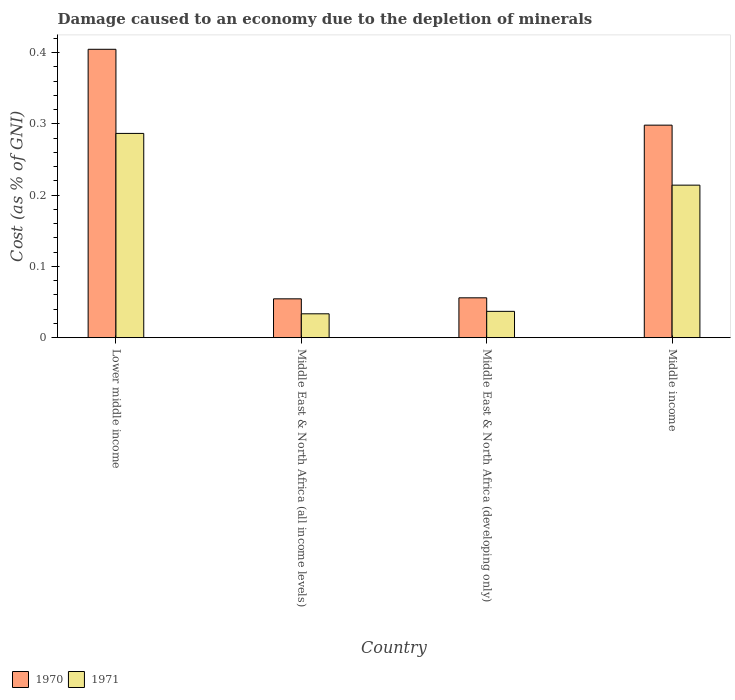How many groups of bars are there?
Give a very brief answer. 4. How many bars are there on the 3rd tick from the right?
Ensure brevity in your answer.  2. What is the cost of damage caused due to the depletion of minerals in 1971 in Middle East & North Africa (developing only)?
Give a very brief answer. 0.04. Across all countries, what is the maximum cost of damage caused due to the depletion of minerals in 1971?
Ensure brevity in your answer.  0.29. Across all countries, what is the minimum cost of damage caused due to the depletion of minerals in 1970?
Offer a terse response. 0.05. In which country was the cost of damage caused due to the depletion of minerals in 1971 maximum?
Offer a terse response. Lower middle income. In which country was the cost of damage caused due to the depletion of minerals in 1971 minimum?
Your answer should be very brief. Middle East & North Africa (all income levels). What is the total cost of damage caused due to the depletion of minerals in 1970 in the graph?
Your response must be concise. 0.81. What is the difference between the cost of damage caused due to the depletion of minerals in 1971 in Lower middle income and that in Middle East & North Africa (all income levels)?
Your answer should be very brief. 0.25. What is the difference between the cost of damage caused due to the depletion of minerals in 1970 in Middle income and the cost of damage caused due to the depletion of minerals in 1971 in Middle East & North Africa (developing only)?
Offer a very short reply. 0.26. What is the average cost of damage caused due to the depletion of minerals in 1971 per country?
Make the answer very short. 0.14. What is the difference between the cost of damage caused due to the depletion of minerals of/in 1970 and cost of damage caused due to the depletion of minerals of/in 1971 in Lower middle income?
Give a very brief answer. 0.12. In how many countries, is the cost of damage caused due to the depletion of minerals in 1971 greater than 0.30000000000000004 %?
Offer a very short reply. 0. What is the ratio of the cost of damage caused due to the depletion of minerals in 1971 in Lower middle income to that in Middle East & North Africa (developing only)?
Ensure brevity in your answer.  7.76. Is the difference between the cost of damage caused due to the depletion of minerals in 1970 in Lower middle income and Middle East & North Africa (developing only) greater than the difference between the cost of damage caused due to the depletion of minerals in 1971 in Lower middle income and Middle East & North Africa (developing only)?
Offer a very short reply. Yes. What is the difference between the highest and the second highest cost of damage caused due to the depletion of minerals in 1971?
Offer a very short reply. 0.25. What is the difference between the highest and the lowest cost of damage caused due to the depletion of minerals in 1970?
Keep it short and to the point. 0.35. In how many countries, is the cost of damage caused due to the depletion of minerals in 1971 greater than the average cost of damage caused due to the depletion of minerals in 1971 taken over all countries?
Offer a terse response. 2. What does the 2nd bar from the left in Middle East & North Africa (all income levels) represents?
Your response must be concise. 1971. What does the 1st bar from the right in Lower middle income represents?
Your response must be concise. 1971. How many bars are there?
Offer a terse response. 8. Are the values on the major ticks of Y-axis written in scientific E-notation?
Ensure brevity in your answer.  No. Does the graph contain grids?
Ensure brevity in your answer.  No. Where does the legend appear in the graph?
Your answer should be very brief. Bottom left. How many legend labels are there?
Ensure brevity in your answer.  2. What is the title of the graph?
Provide a succinct answer. Damage caused to an economy due to the depletion of minerals. What is the label or title of the X-axis?
Your answer should be compact. Country. What is the label or title of the Y-axis?
Provide a succinct answer. Cost (as % of GNI). What is the Cost (as % of GNI) of 1970 in Lower middle income?
Provide a short and direct response. 0.4. What is the Cost (as % of GNI) of 1971 in Lower middle income?
Offer a very short reply. 0.29. What is the Cost (as % of GNI) of 1970 in Middle East & North Africa (all income levels)?
Ensure brevity in your answer.  0.05. What is the Cost (as % of GNI) in 1971 in Middle East & North Africa (all income levels)?
Your answer should be compact. 0.03. What is the Cost (as % of GNI) in 1970 in Middle East & North Africa (developing only)?
Give a very brief answer. 0.06. What is the Cost (as % of GNI) in 1971 in Middle East & North Africa (developing only)?
Your answer should be very brief. 0.04. What is the Cost (as % of GNI) of 1970 in Middle income?
Provide a short and direct response. 0.3. What is the Cost (as % of GNI) in 1971 in Middle income?
Give a very brief answer. 0.21. Across all countries, what is the maximum Cost (as % of GNI) in 1970?
Provide a short and direct response. 0.4. Across all countries, what is the maximum Cost (as % of GNI) of 1971?
Offer a terse response. 0.29. Across all countries, what is the minimum Cost (as % of GNI) of 1970?
Offer a very short reply. 0.05. Across all countries, what is the minimum Cost (as % of GNI) of 1971?
Keep it short and to the point. 0.03. What is the total Cost (as % of GNI) of 1970 in the graph?
Ensure brevity in your answer.  0.81. What is the total Cost (as % of GNI) in 1971 in the graph?
Your answer should be compact. 0.57. What is the difference between the Cost (as % of GNI) in 1970 in Lower middle income and that in Middle East & North Africa (all income levels)?
Keep it short and to the point. 0.35. What is the difference between the Cost (as % of GNI) in 1971 in Lower middle income and that in Middle East & North Africa (all income levels)?
Your answer should be compact. 0.25. What is the difference between the Cost (as % of GNI) of 1970 in Lower middle income and that in Middle East & North Africa (developing only)?
Your response must be concise. 0.35. What is the difference between the Cost (as % of GNI) in 1971 in Lower middle income and that in Middle East & North Africa (developing only)?
Your answer should be very brief. 0.25. What is the difference between the Cost (as % of GNI) of 1970 in Lower middle income and that in Middle income?
Your answer should be very brief. 0.11. What is the difference between the Cost (as % of GNI) of 1971 in Lower middle income and that in Middle income?
Your response must be concise. 0.07. What is the difference between the Cost (as % of GNI) of 1970 in Middle East & North Africa (all income levels) and that in Middle East & North Africa (developing only)?
Provide a short and direct response. -0. What is the difference between the Cost (as % of GNI) in 1971 in Middle East & North Africa (all income levels) and that in Middle East & North Africa (developing only)?
Provide a succinct answer. -0. What is the difference between the Cost (as % of GNI) in 1970 in Middle East & North Africa (all income levels) and that in Middle income?
Provide a succinct answer. -0.24. What is the difference between the Cost (as % of GNI) in 1971 in Middle East & North Africa (all income levels) and that in Middle income?
Provide a short and direct response. -0.18. What is the difference between the Cost (as % of GNI) in 1970 in Middle East & North Africa (developing only) and that in Middle income?
Offer a very short reply. -0.24. What is the difference between the Cost (as % of GNI) in 1971 in Middle East & North Africa (developing only) and that in Middle income?
Your answer should be very brief. -0.18. What is the difference between the Cost (as % of GNI) in 1970 in Lower middle income and the Cost (as % of GNI) in 1971 in Middle East & North Africa (all income levels)?
Your response must be concise. 0.37. What is the difference between the Cost (as % of GNI) of 1970 in Lower middle income and the Cost (as % of GNI) of 1971 in Middle East & North Africa (developing only)?
Ensure brevity in your answer.  0.37. What is the difference between the Cost (as % of GNI) in 1970 in Lower middle income and the Cost (as % of GNI) in 1971 in Middle income?
Offer a very short reply. 0.19. What is the difference between the Cost (as % of GNI) of 1970 in Middle East & North Africa (all income levels) and the Cost (as % of GNI) of 1971 in Middle East & North Africa (developing only)?
Give a very brief answer. 0.02. What is the difference between the Cost (as % of GNI) in 1970 in Middle East & North Africa (all income levels) and the Cost (as % of GNI) in 1971 in Middle income?
Your answer should be compact. -0.16. What is the difference between the Cost (as % of GNI) of 1970 in Middle East & North Africa (developing only) and the Cost (as % of GNI) of 1971 in Middle income?
Offer a very short reply. -0.16. What is the average Cost (as % of GNI) in 1970 per country?
Make the answer very short. 0.2. What is the average Cost (as % of GNI) of 1971 per country?
Offer a very short reply. 0.14. What is the difference between the Cost (as % of GNI) in 1970 and Cost (as % of GNI) in 1971 in Lower middle income?
Give a very brief answer. 0.12. What is the difference between the Cost (as % of GNI) of 1970 and Cost (as % of GNI) of 1971 in Middle East & North Africa (all income levels)?
Your answer should be compact. 0.02. What is the difference between the Cost (as % of GNI) of 1970 and Cost (as % of GNI) of 1971 in Middle East & North Africa (developing only)?
Keep it short and to the point. 0.02. What is the difference between the Cost (as % of GNI) of 1970 and Cost (as % of GNI) of 1971 in Middle income?
Keep it short and to the point. 0.08. What is the ratio of the Cost (as % of GNI) in 1970 in Lower middle income to that in Middle East & North Africa (all income levels)?
Provide a succinct answer. 7.43. What is the ratio of the Cost (as % of GNI) of 1971 in Lower middle income to that in Middle East & North Africa (all income levels)?
Ensure brevity in your answer.  8.56. What is the ratio of the Cost (as % of GNI) in 1970 in Lower middle income to that in Middle East & North Africa (developing only)?
Give a very brief answer. 7.24. What is the ratio of the Cost (as % of GNI) in 1971 in Lower middle income to that in Middle East & North Africa (developing only)?
Ensure brevity in your answer.  7.76. What is the ratio of the Cost (as % of GNI) of 1970 in Lower middle income to that in Middle income?
Make the answer very short. 1.36. What is the ratio of the Cost (as % of GNI) of 1971 in Lower middle income to that in Middle income?
Offer a terse response. 1.34. What is the ratio of the Cost (as % of GNI) of 1970 in Middle East & North Africa (all income levels) to that in Middle East & North Africa (developing only)?
Offer a terse response. 0.97. What is the ratio of the Cost (as % of GNI) in 1971 in Middle East & North Africa (all income levels) to that in Middle East & North Africa (developing only)?
Make the answer very short. 0.91. What is the ratio of the Cost (as % of GNI) of 1970 in Middle East & North Africa (all income levels) to that in Middle income?
Make the answer very short. 0.18. What is the ratio of the Cost (as % of GNI) in 1971 in Middle East & North Africa (all income levels) to that in Middle income?
Your response must be concise. 0.16. What is the ratio of the Cost (as % of GNI) of 1970 in Middle East & North Africa (developing only) to that in Middle income?
Make the answer very short. 0.19. What is the ratio of the Cost (as % of GNI) of 1971 in Middle East & North Africa (developing only) to that in Middle income?
Provide a succinct answer. 0.17. What is the difference between the highest and the second highest Cost (as % of GNI) of 1970?
Make the answer very short. 0.11. What is the difference between the highest and the second highest Cost (as % of GNI) in 1971?
Keep it short and to the point. 0.07. What is the difference between the highest and the lowest Cost (as % of GNI) of 1970?
Provide a short and direct response. 0.35. What is the difference between the highest and the lowest Cost (as % of GNI) of 1971?
Provide a succinct answer. 0.25. 